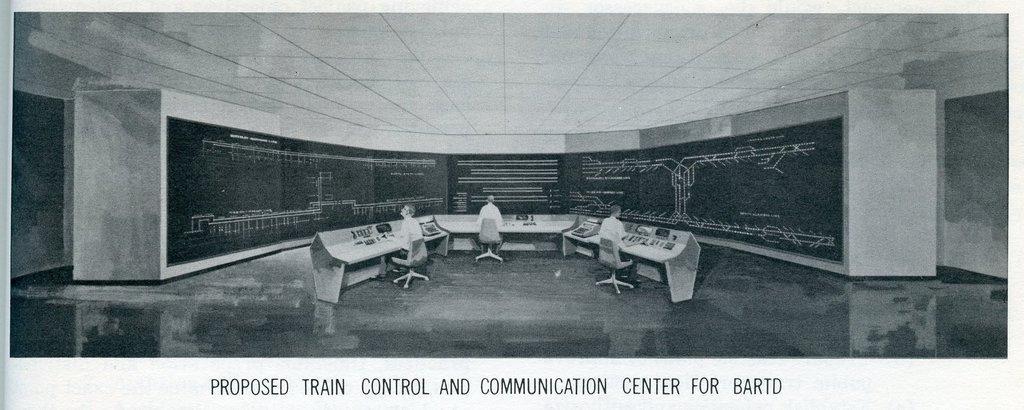Could you give a brief overview of what you see in this image? In this picture, we can see a poster with some images like a few people sitting in a chair, table, big screen, ground, roof, and the wall, and we can see some text in the bottom side of the picture. 